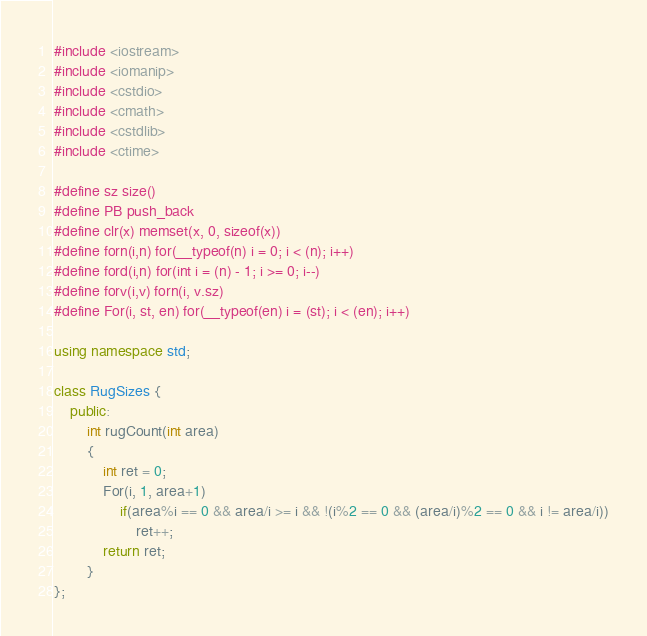Convert code to text. <code><loc_0><loc_0><loc_500><loc_500><_C++_>#include <iostream>
#include <iomanip>
#include <cstdio>
#include <cmath>
#include <cstdlib>
#include <ctime>

#define sz size()
#define PB push_back
#define clr(x) memset(x, 0, sizeof(x))
#define forn(i,n) for(__typeof(n) i = 0; i < (n); i++)
#define ford(i,n) for(int i = (n) - 1; i >= 0; i--)
#define forv(i,v) forn(i, v.sz)
#define For(i, st, en) for(__typeof(en) i = (st); i < (en); i++)

using namespace std;

class RugSizes {
	public:
		int rugCount(int area) 
		{		
			int ret = 0;
			For(i, 1, area+1)
				if(area%i == 0 && area/i >= i && !(i%2 == 0 && (area/i)%2 == 0 && i != area/i))
					ret++;
			return ret;
		}
};
</code> 